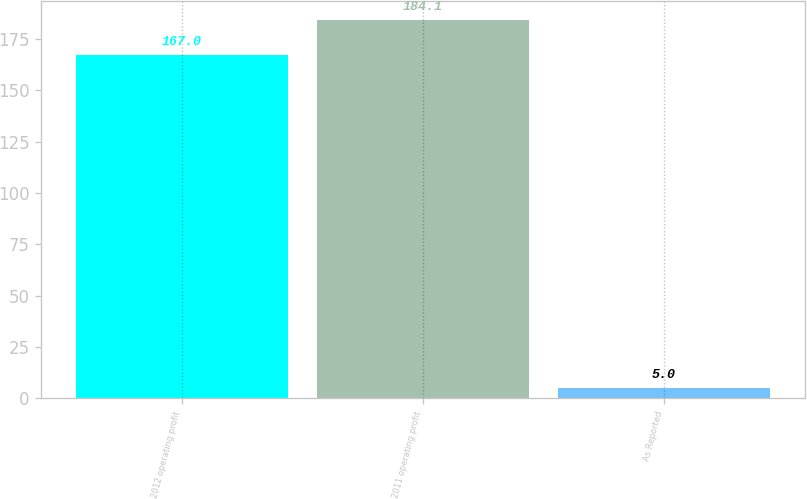Convert chart. <chart><loc_0><loc_0><loc_500><loc_500><bar_chart><fcel>2012 operating profit<fcel>2011 operating profit<fcel>As Reported<nl><fcel>167<fcel>184.1<fcel>5<nl></chart> 